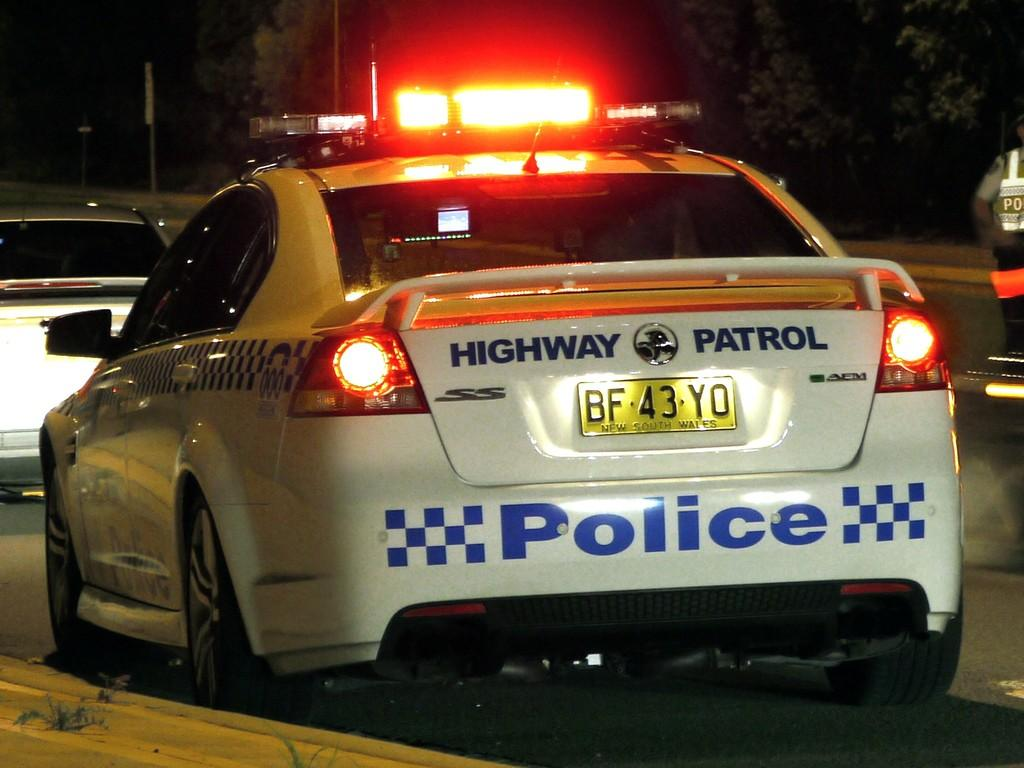What type of vehicles can be seen in the image? There are cars in the image. What other objects or elements are present in the image? There are trees in the image. What type of comb is being used to style the trees in the image? There is no comb present in the image, and the trees are not being styled. 